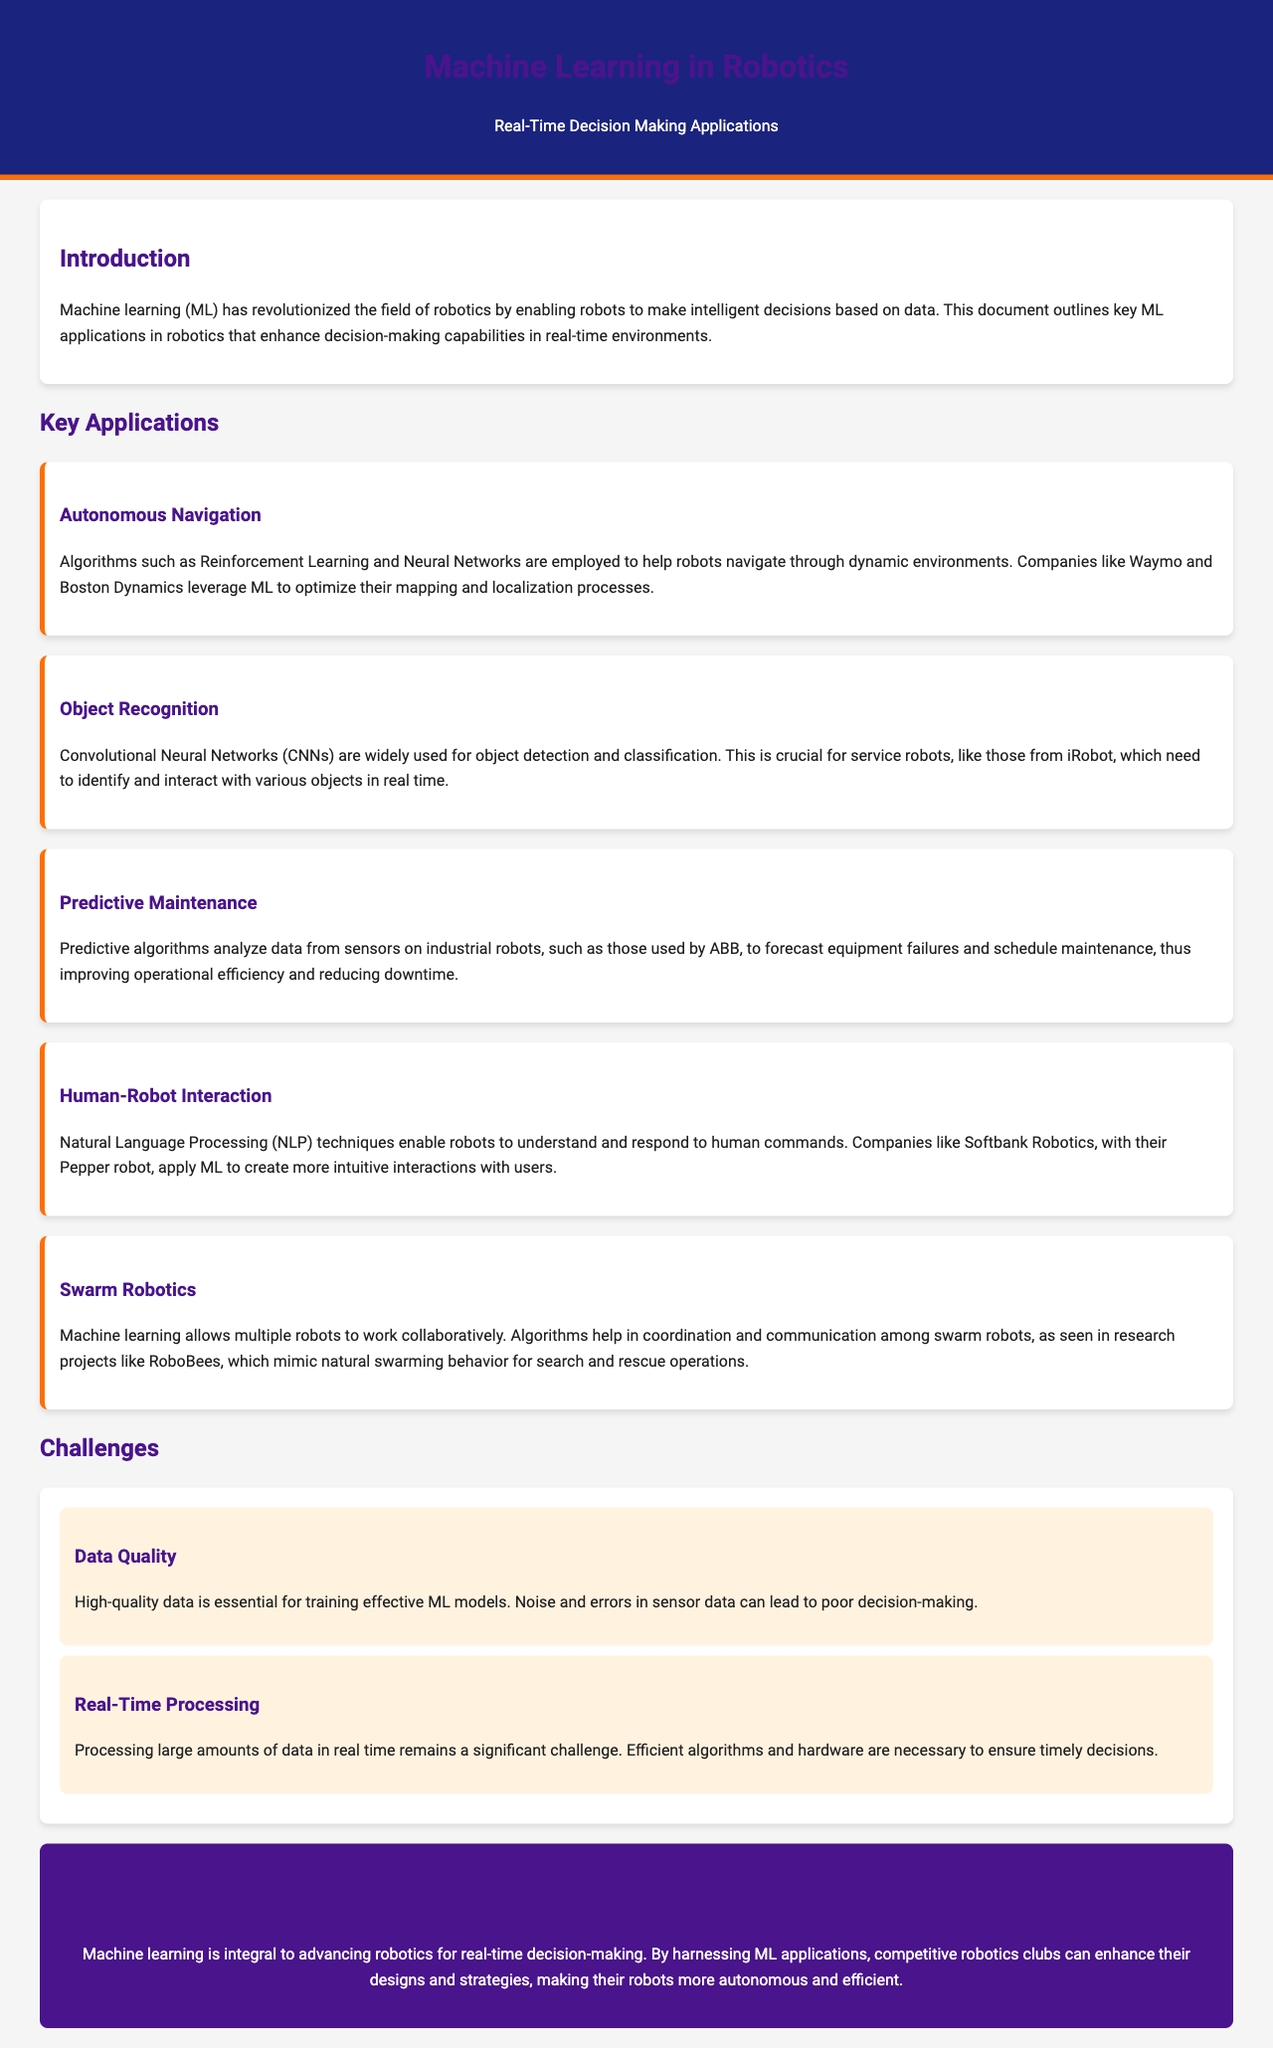What is the main focus of this document? The document outlines key machine learning applications in robotics that enhance decision-making capabilities in real-time environments.
Answer: Machine learning applications in robotics for real-time decision making Which company uses Reinforcement Learning for autonomous navigation? The document mentions that Waymo employs Reinforcement Learning and Neural Networks for navigation.
Answer: Waymo What is the function of Convolutional Neural Networks in robotics? CNNs are widely used for object detection and classification, crucial for service robots.
Answer: Object detection and classification What algorithm is used for predictive maintenance? The document states that predictive algorithms are used to analyze sensor data to forecast equipment failures.
Answer: Predictive algorithms Name one challenge related to machine learning in robotics. The document cites high-quality data as essential for training effective ML models.
Answer: Data Quality Which company applies Natural Language Processing techniques in human-robot interaction? The document lists Softbank Robotics as a company that applies NLP in its Pepper robot.
Answer: Softbank Robotics What do swarm robots mimic according to the document? The document indicates that swarm robots mimic natural swarming behavior for search and rescue operations.
Answer: Natural swarming behavior What is a significant challenge in real-time processing mentioned in the document? The document highlights the need for efficient algorithms and hardware to ensure timely decisions in processing large amounts of data.
Answer: Efficient algorithms and hardware 